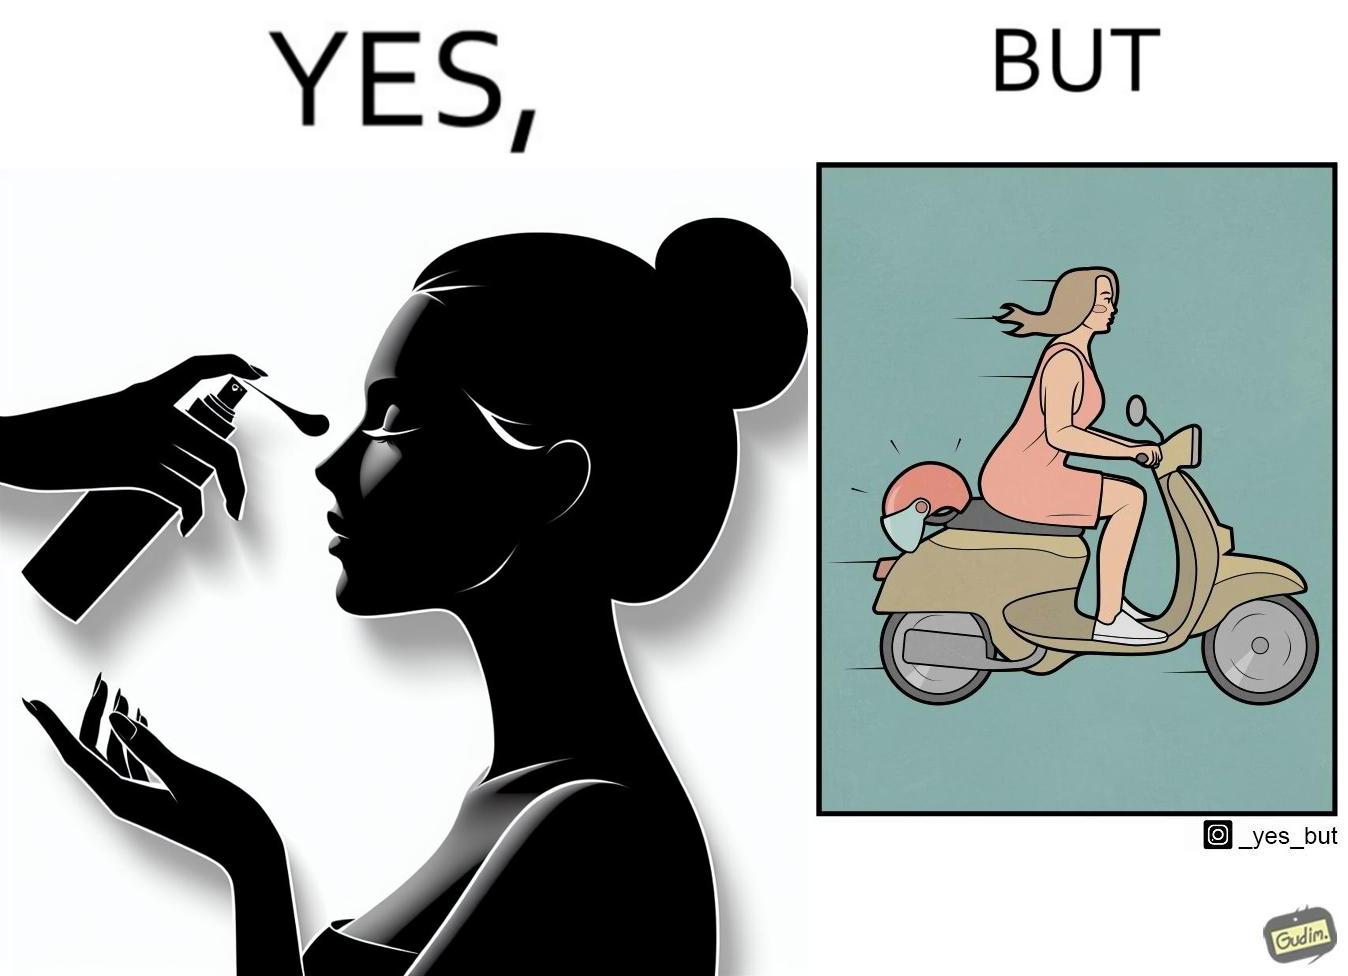What do you see in each half of this image? In the left part of the image: The image shows a woman applying sunscreen with high SPF on her face. In the right part of the image: The image shows a woman riding a scooter with her helmet on the back seat. 